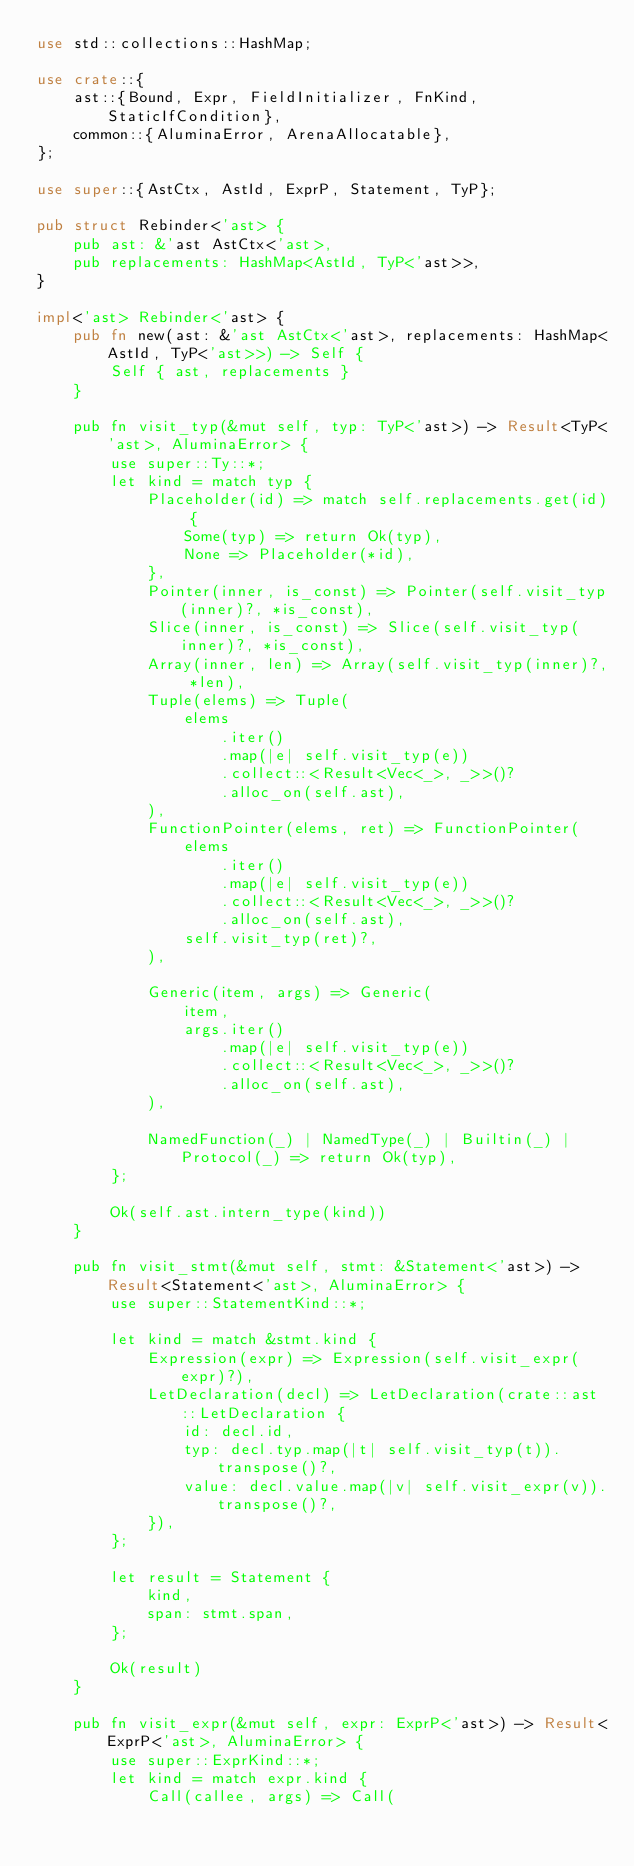Convert code to text. <code><loc_0><loc_0><loc_500><loc_500><_Rust_>use std::collections::HashMap;

use crate::{
    ast::{Bound, Expr, FieldInitializer, FnKind, StaticIfCondition},
    common::{AluminaError, ArenaAllocatable},
};

use super::{AstCtx, AstId, ExprP, Statement, TyP};

pub struct Rebinder<'ast> {
    pub ast: &'ast AstCtx<'ast>,
    pub replacements: HashMap<AstId, TyP<'ast>>,
}

impl<'ast> Rebinder<'ast> {
    pub fn new(ast: &'ast AstCtx<'ast>, replacements: HashMap<AstId, TyP<'ast>>) -> Self {
        Self { ast, replacements }
    }

    pub fn visit_typ(&mut self, typ: TyP<'ast>) -> Result<TyP<'ast>, AluminaError> {
        use super::Ty::*;
        let kind = match typ {
            Placeholder(id) => match self.replacements.get(id) {
                Some(typ) => return Ok(typ),
                None => Placeholder(*id),
            },
            Pointer(inner, is_const) => Pointer(self.visit_typ(inner)?, *is_const),
            Slice(inner, is_const) => Slice(self.visit_typ(inner)?, *is_const),
            Array(inner, len) => Array(self.visit_typ(inner)?, *len),
            Tuple(elems) => Tuple(
                elems
                    .iter()
                    .map(|e| self.visit_typ(e))
                    .collect::<Result<Vec<_>, _>>()?
                    .alloc_on(self.ast),
            ),
            FunctionPointer(elems, ret) => FunctionPointer(
                elems
                    .iter()
                    .map(|e| self.visit_typ(e))
                    .collect::<Result<Vec<_>, _>>()?
                    .alloc_on(self.ast),
                self.visit_typ(ret)?,
            ),

            Generic(item, args) => Generic(
                item,
                args.iter()
                    .map(|e| self.visit_typ(e))
                    .collect::<Result<Vec<_>, _>>()?
                    .alloc_on(self.ast),
            ),

            NamedFunction(_) | NamedType(_) | Builtin(_) | Protocol(_) => return Ok(typ),
        };

        Ok(self.ast.intern_type(kind))
    }

    pub fn visit_stmt(&mut self, stmt: &Statement<'ast>) -> Result<Statement<'ast>, AluminaError> {
        use super::StatementKind::*;

        let kind = match &stmt.kind {
            Expression(expr) => Expression(self.visit_expr(expr)?),
            LetDeclaration(decl) => LetDeclaration(crate::ast::LetDeclaration {
                id: decl.id,
                typ: decl.typ.map(|t| self.visit_typ(t)).transpose()?,
                value: decl.value.map(|v| self.visit_expr(v)).transpose()?,
            }),
        };

        let result = Statement {
            kind,
            span: stmt.span,
        };

        Ok(result)
    }

    pub fn visit_expr(&mut self, expr: ExprP<'ast>) -> Result<ExprP<'ast>, AluminaError> {
        use super::ExprKind::*;
        let kind = match expr.kind {
            Call(callee, args) => Call(</code> 